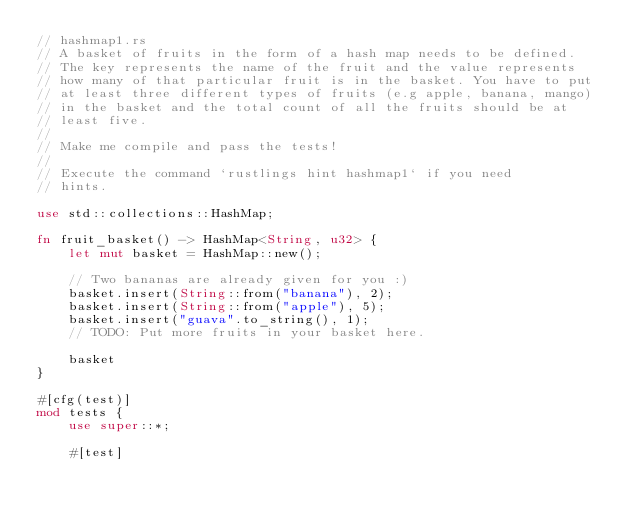<code> <loc_0><loc_0><loc_500><loc_500><_Rust_>// hashmap1.rs
// A basket of fruits in the form of a hash map needs to be defined.
// The key represents the name of the fruit and the value represents
// how many of that particular fruit is in the basket. You have to put
// at least three different types of fruits (e.g apple, banana, mango)
// in the basket and the total count of all the fruits should be at
// least five.
//
// Make me compile and pass the tests!
//
// Execute the command `rustlings hint hashmap1` if you need
// hints.

use std::collections::HashMap;

fn fruit_basket() -> HashMap<String, u32> {
    let mut basket = HashMap::new();

    // Two bananas are already given for you :)
    basket.insert(String::from("banana"), 2);
    basket.insert(String::from("apple"), 5);
    basket.insert("guava".to_string(), 1);
    // TODO: Put more fruits in your basket here.

    basket
}

#[cfg(test)]
mod tests {
    use super::*;

    #[test]</code> 